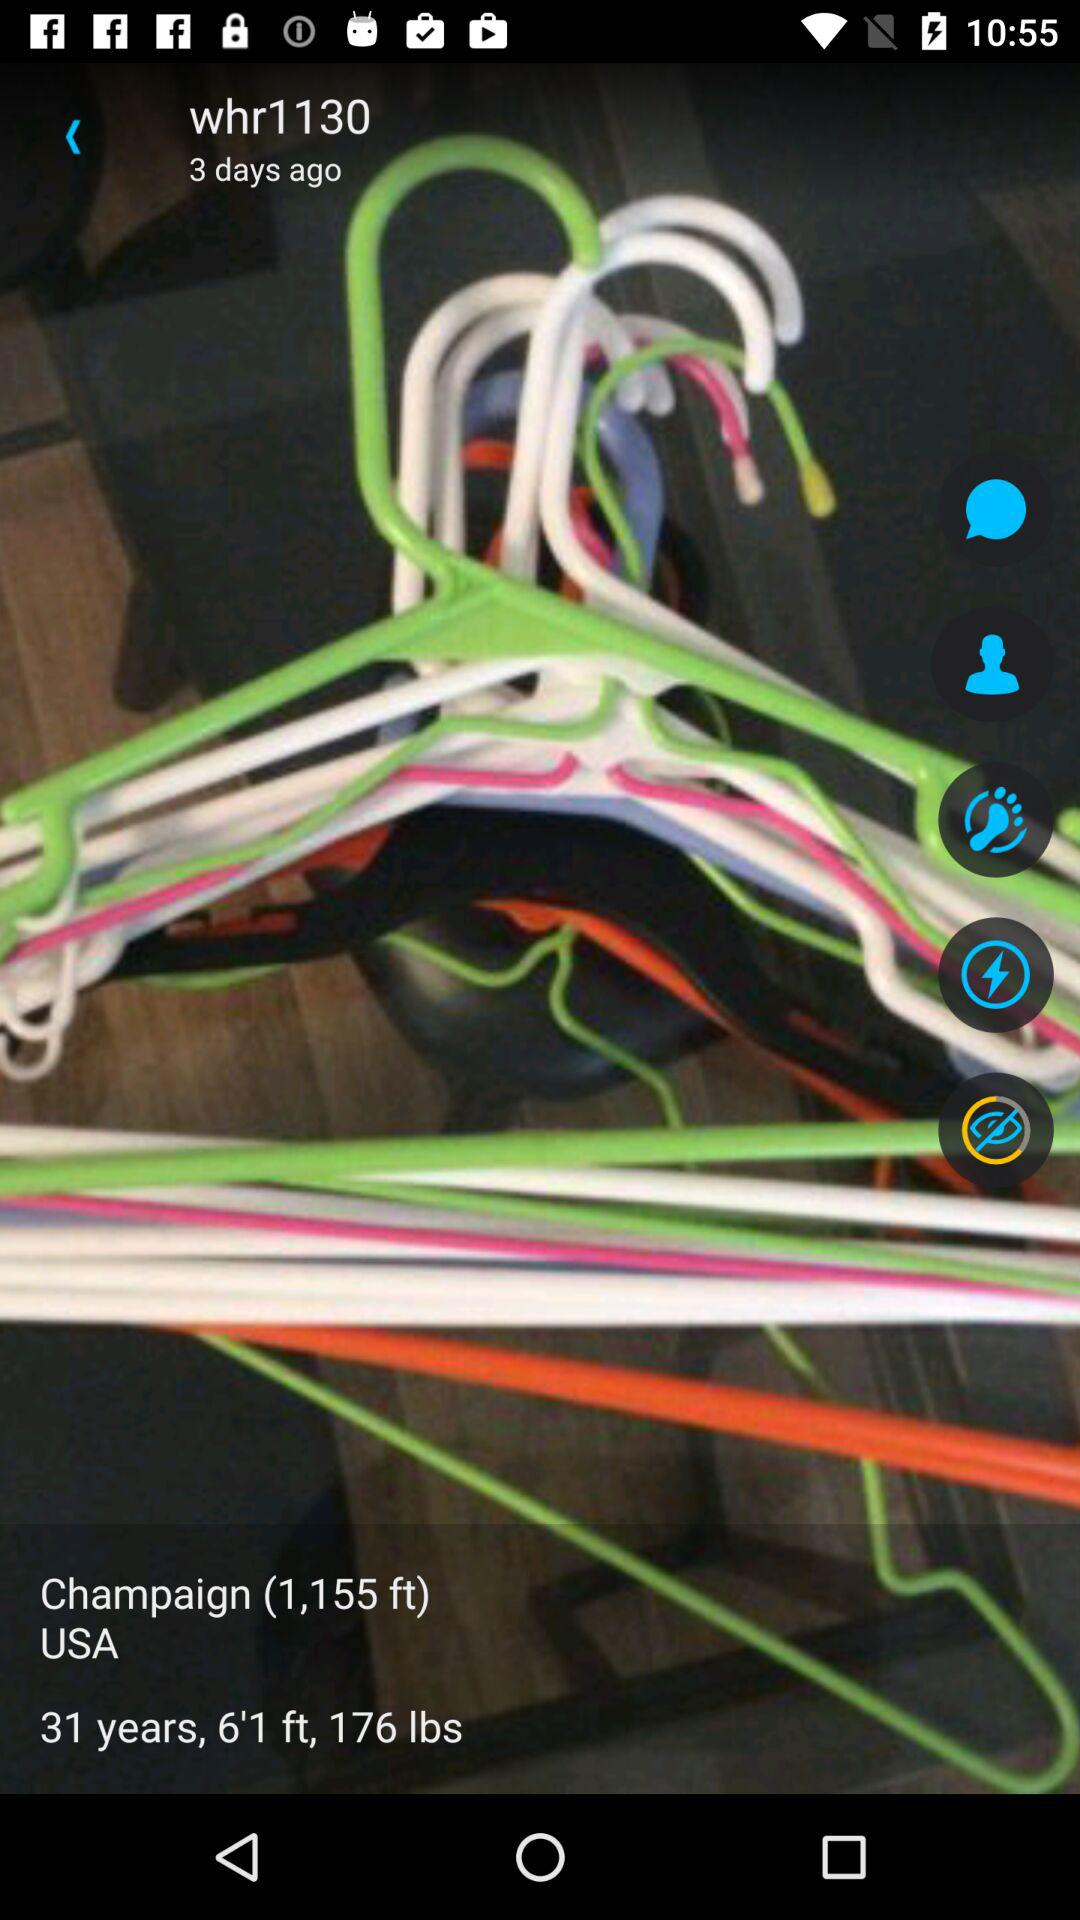What is the location? The location is Champaign, USA. 